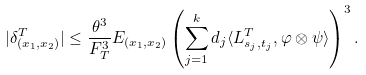Convert formula to latex. <formula><loc_0><loc_0><loc_500><loc_500>| \delta _ { ( x _ { 1 } , x _ { 2 } ) } ^ { T } | \leq \frac { \theta ^ { 3 } } { F _ { T } ^ { 3 } } E _ { ( x _ { 1 } , x _ { 2 } ) } \left ( \sum _ { j = 1 } ^ { k } d _ { j } \langle L ^ { T } _ { s _ { j } , t _ { j } } , \varphi \otimes \psi \rangle \right ) ^ { 3 } .</formula> 